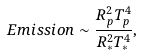Convert formula to latex. <formula><loc_0><loc_0><loc_500><loc_500>E m i s s i o n \sim \frac { R _ { p } ^ { 2 } T _ { p } ^ { 4 } } { R _ { * } ^ { 2 } T _ { * } ^ { 4 } } ,</formula> 